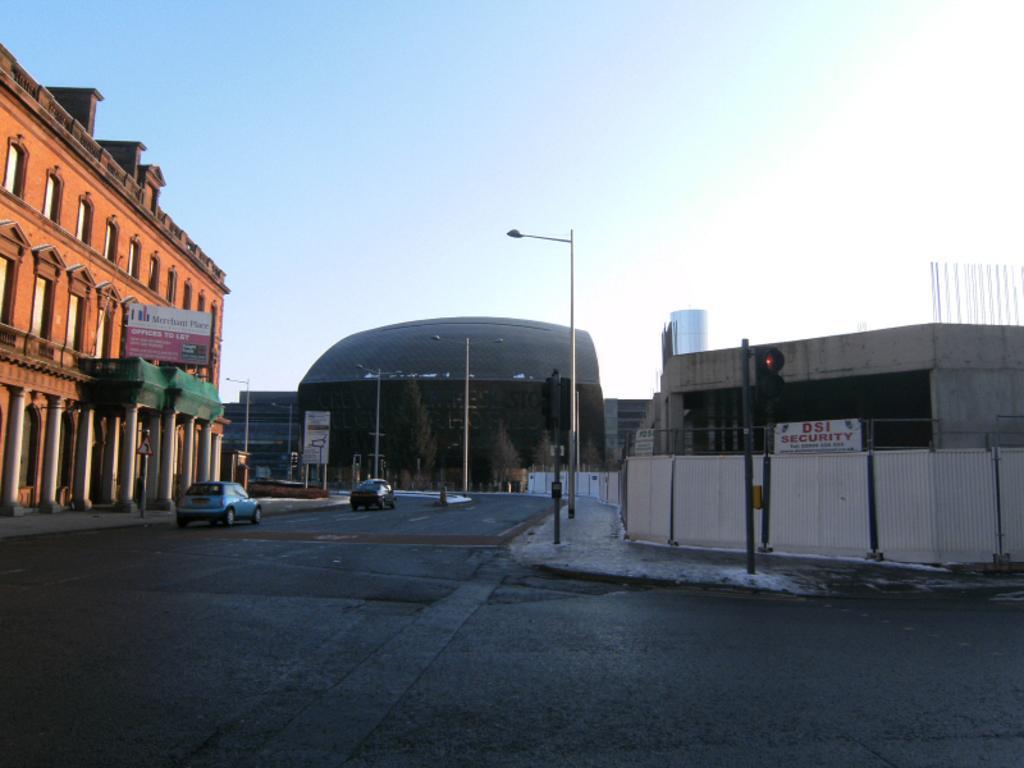In one or two sentences, can you explain what this image depicts? In the picture there are two vehicles moving on the road and around the road there are tall buildings and street lights and on the right side there is a traffic signal pole, behind that there is a security office. 